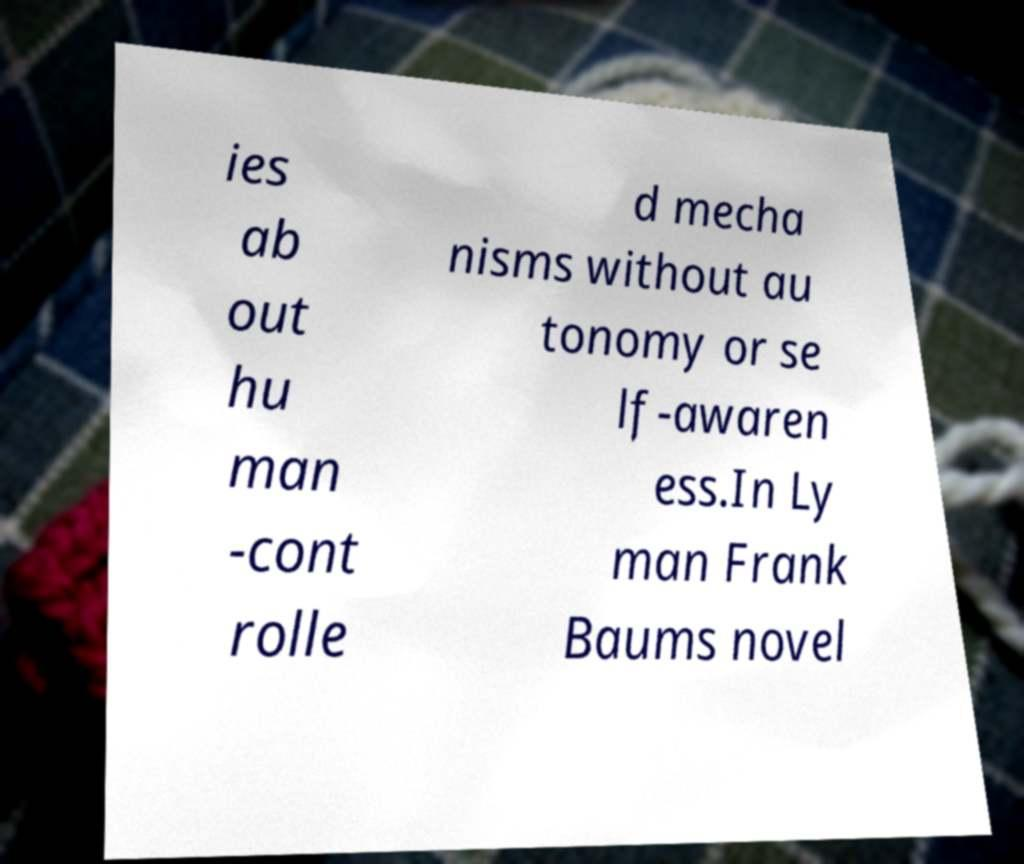I need the written content from this picture converted into text. Can you do that? ies ab out hu man -cont rolle d mecha nisms without au tonomy or se lf-awaren ess.In Ly man Frank Baums novel 